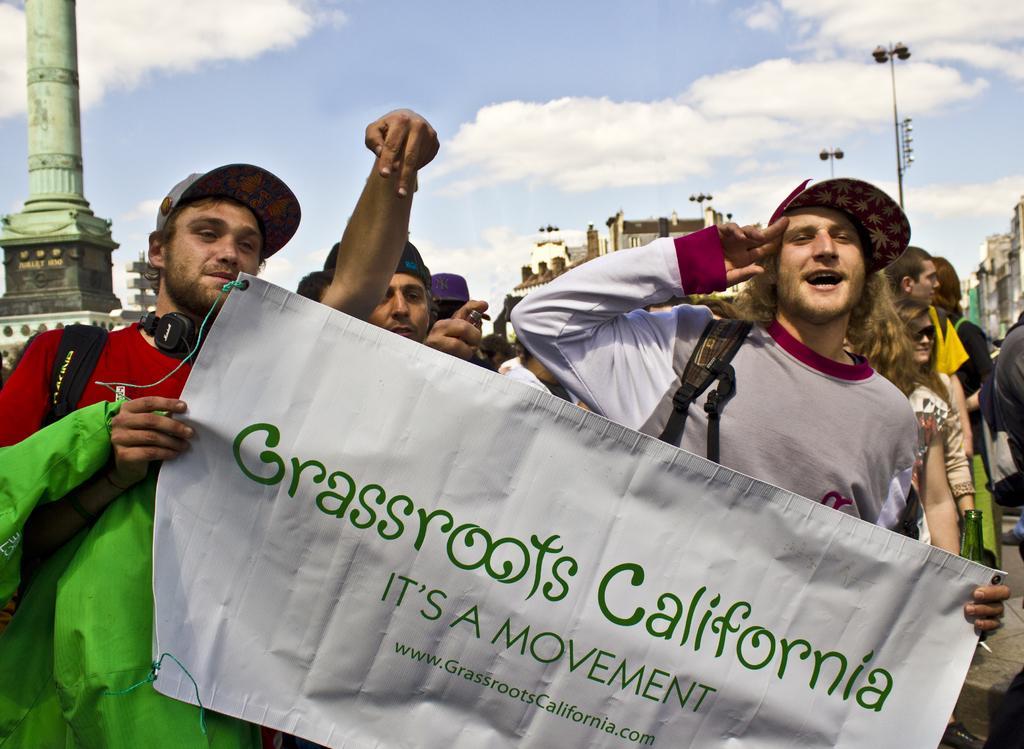Can you describe this image briefly? Front these two people are holding a banner. Background we can see buildings, light poles, pillar and people. Those are clouds in the sky. 